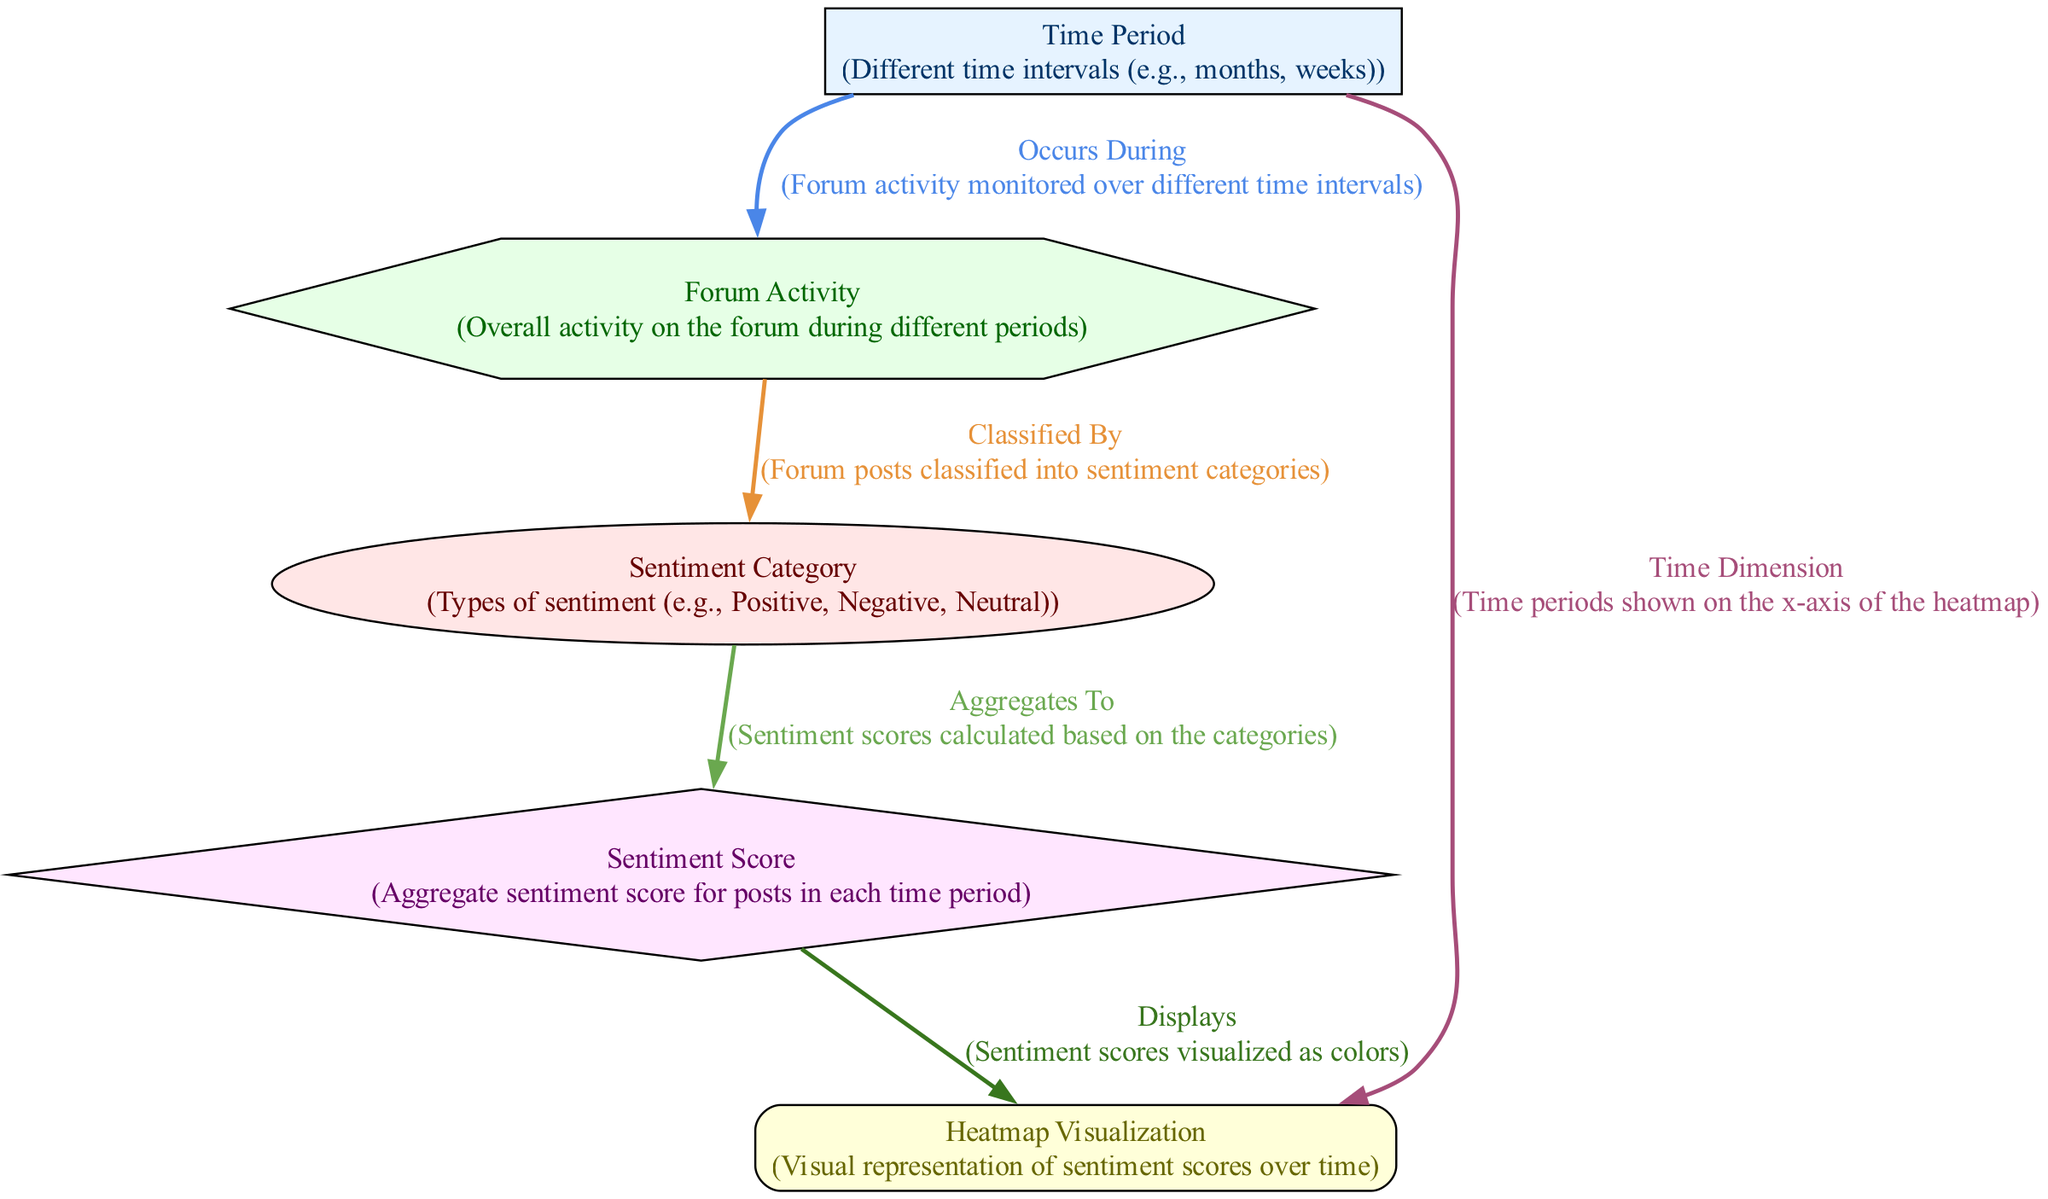What are the two sentiment categories displayed in the diagram? The diagram shows the nodes representing sentiment categories, which are labeled "Positive" and "Negative".
Answer: Positive, Negative How many nodes are present in the diagram? The diagram consists of five nodes: Time Period, Sentiment Category, Forum Activity, Sentiment Score, and Heatmap Visualization.
Answer: 5 What type of visualization is used to represent sentiment scores over time? The node labeled "Heatmap Visualization" indicates that a heatmap is used to display the sentiment scores visually.
Answer: Heatmap What does the edge labeled "Classified By" represent? This edge points from "Forum Activity" to "Sentiment Category", indicating that forum posts are classified based on different sentiment categories.
Answer: Forum posts classification What relationship does the edge from "Sentiment Category" to "Sentiment Score" illustrate? This edge labeled "Aggregates To" shows that sentiment scores are computed by aggregating data from the different sentiment categories.
Answer: Computation of sentiment scores How does the "Time Period" node affect the "Heatmap Visualization"? The edge labeled "Time Dimension" illustrates that "Time Period" directly influences the x-axis representation of the heatmap visualization.
Answer: Affects x-axis representation Which sentiment category contributes to a higher sentiment score in the aggregate? To determine this, one must review the sentiment scores resulting from the aggregation of classified sentiment categories. Presumably, one of the categories will yield a higher score based on forum posts.
Answer: Higher aggregate score from Positive (assumed) How are the sentiment scores displayed visually in the heatmap? The edge from "Sentiment Score" to "Heatmap Visualization" states that sentiment scores are represented as colors on the heatmap.
Answer: Represented as colors What does the "Forum Activity" node indicate about post interactions in the specified time intervals? The edge labeled "Occurs During" indicates that forum activity is monitored in relation to the different time intervals specified by the "Time Period" node.
Answer: Monitored in relation to time intervals What time intervals are monitored for analyzing forum posts? The "Time Period" node implies that the intervals could include months or weeks, indicating the temporal analysis scope for forum activity.
Answer: Months, weeks 